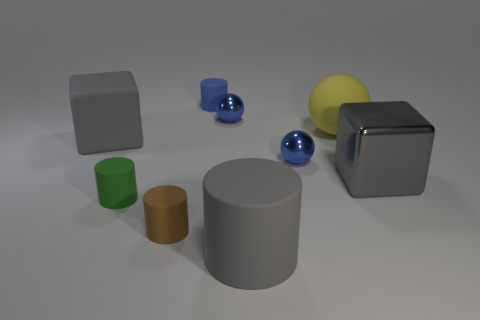What is the shape of the large metal object that is the same color as the large matte cylinder?
Ensure brevity in your answer.  Cube. Are there any big brown metallic cylinders?
Your answer should be very brief. No. There is a blue thing that is made of the same material as the brown thing; what size is it?
Provide a short and direct response. Small. What is the shape of the small rubber object behind the big object behind the large thing left of the big cylinder?
Provide a short and direct response. Cylinder. Are there an equal number of small green rubber cylinders that are right of the large rubber block and small brown cylinders?
Your answer should be compact. Yes. There is a matte block that is the same color as the large cylinder; what is its size?
Ensure brevity in your answer.  Large. Do the small brown rubber object and the blue rubber thing have the same shape?
Your answer should be very brief. Yes. How many things are gray rubber things behind the small green cylinder or big blue matte cylinders?
Ensure brevity in your answer.  1. Is the number of yellow things that are in front of the gray cylinder the same as the number of matte cubes on the left side of the green thing?
Provide a short and direct response. No. What number of other things are there of the same shape as the blue rubber object?
Your answer should be very brief. 3. 